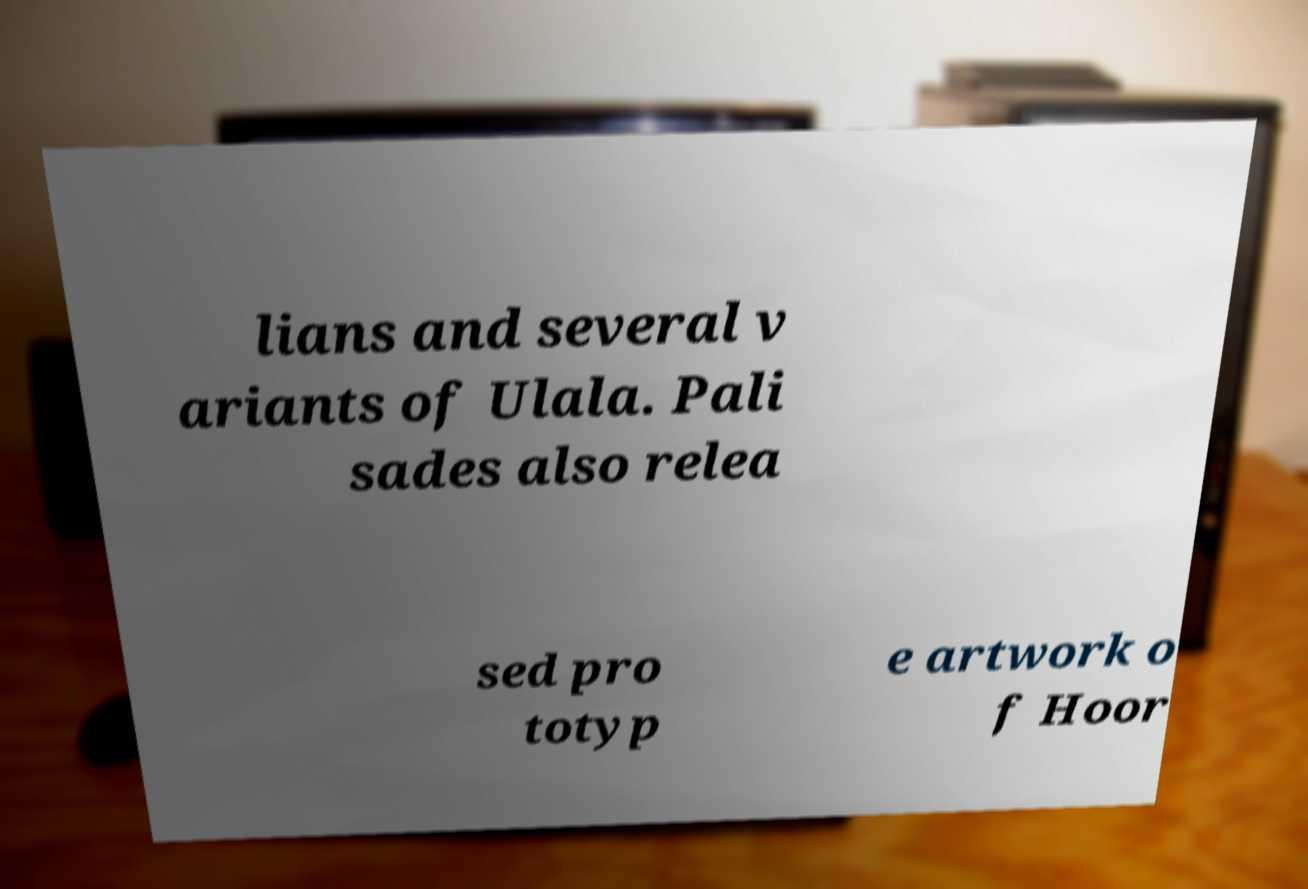Can you read and provide the text displayed in the image?This photo seems to have some interesting text. Can you extract and type it out for me? lians and several v ariants of Ulala. Pali sades also relea sed pro totyp e artwork o f Hoor 